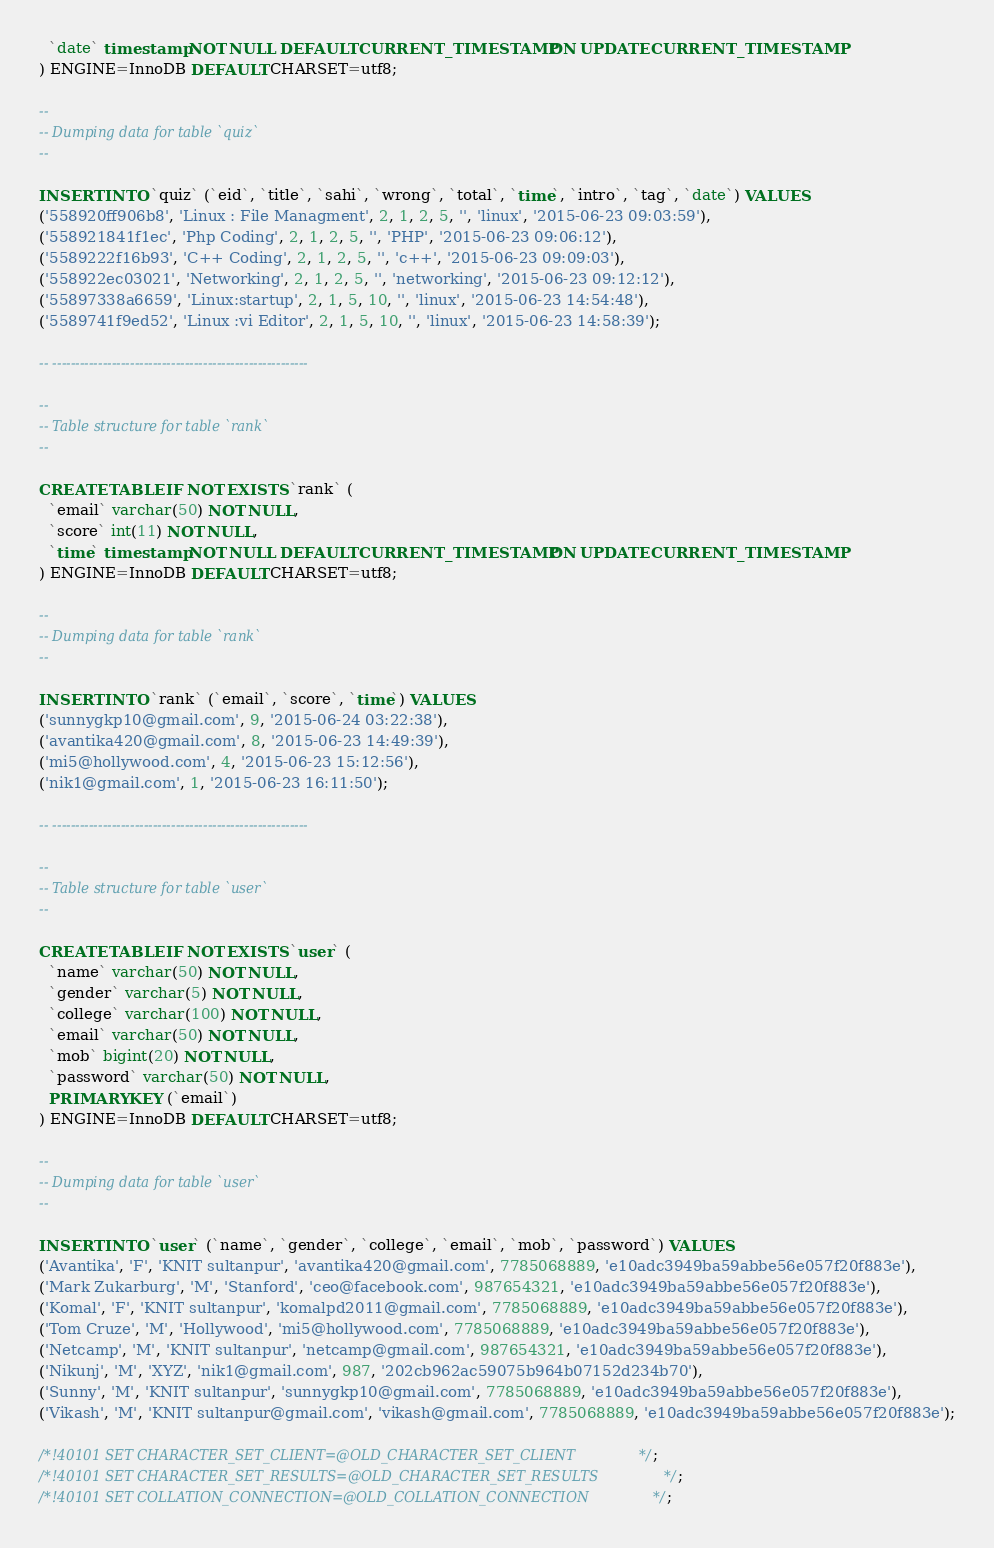Convert code to text. <code><loc_0><loc_0><loc_500><loc_500><_SQL_>  `date` timestamp NOT NULL DEFAULT CURRENT_TIMESTAMP ON UPDATE CURRENT_TIMESTAMP
) ENGINE=InnoDB DEFAULT CHARSET=utf8;

--
-- Dumping data for table `quiz`
--

INSERT INTO `quiz` (`eid`, `title`, `sahi`, `wrong`, `total`, `time`, `intro`, `tag`, `date`) VALUES
('558920ff906b8', 'Linux : File Managment', 2, 1, 2, 5, '', 'linux', '2015-06-23 09:03:59'),
('558921841f1ec', 'Php Coding', 2, 1, 2, 5, '', 'PHP', '2015-06-23 09:06:12'),
('5589222f16b93', 'C++ Coding', 2, 1, 2, 5, '', 'c++', '2015-06-23 09:09:03'),
('558922ec03021', 'Networking', 2, 1, 2, 5, '', 'networking', '2015-06-23 09:12:12'),
('55897338a6659', 'Linux:startup', 2, 1, 5, 10, '', 'linux', '2015-06-23 14:54:48'),
('5589741f9ed52', 'Linux :vi Editor', 2, 1, 5, 10, '', 'linux', '2015-06-23 14:58:39');

-- --------------------------------------------------------

--
-- Table structure for table `rank`
--

CREATE TABLE IF NOT EXISTS `rank` (
  `email` varchar(50) NOT NULL,
  `score` int(11) NOT NULL,
  `time` timestamp NOT NULL DEFAULT CURRENT_TIMESTAMP ON UPDATE CURRENT_TIMESTAMP
) ENGINE=InnoDB DEFAULT CHARSET=utf8;

--
-- Dumping data for table `rank`
--

INSERT INTO `rank` (`email`, `score`, `time`) VALUES
('sunnygkp10@gmail.com', 9, '2015-06-24 03:22:38'),
('avantika420@gmail.com', 8, '2015-06-23 14:49:39'),
('mi5@hollywood.com', 4, '2015-06-23 15:12:56'),
('nik1@gmail.com', 1, '2015-06-23 16:11:50');

-- --------------------------------------------------------

--
-- Table structure for table `user`
--

CREATE TABLE IF NOT EXISTS `user` (
  `name` varchar(50) NOT NULL,
  `gender` varchar(5) NOT NULL,
  `college` varchar(100) NOT NULL,
  `email` varchar(50) NOT NULL,
  `mob` bigint(20) NOT NULL,
  `password` varchar(50) NOT NULL,
  PRIMARY KEY (`email`)
) ENGINE=InnoDB DEFAULT CHARSET=utf8;

--
-- Dumping data for table `user`
--

INSERT INTO `user` (`name`, `gender`, `college`, `email`, `mob`, `password`) VALUES
('Avantika', 'F', 'KNIT sultanpur', 'avantika420@gmail.com', 7785068889, 'e10adc3949ba59abbe56e057f20f883e'),
('Mark Zukarburg', 'M', 'Stanford', 'ceo@facebook.com', 987654321, 'e10adc3949ba59abbe56e057f20f883e'),
('Komal', 'F', 'KNIT sultanpur', 'komalpd2011@gmail.com', 7785068889, 'e10adc3949ba59abbe56e057f20f883e'),
('Tom Cruze', 'M', 'Hollywood', 'mi5@hollywood.com', 7785068889, 'e10adc3949ba59abbe56e057f20f883e'),
('Netcamp', 'M', 'KNIT sultanpur', 'netcamp@gmail.com', 987654321, 'e10adc3949ba59abbe56e057f20f883e'),
('Nikunj', 'M', 'XYZ', 'nik1@gmail.com', 987, '202cb962ac59075b964b07152d234b70'),
('Sunny', 'M', 'KNIT sultanpur', 'sunnygkp10@gmail.com', 7785068889, 'e10adc3949ba59abbe56e057f20f883e'),
('Vikash', 'M', 'KNIT sultanpur@gmail.com', 'vikash@gmail.com', 7785068889, 'e10adc3949ba59abbe56e057f20f883e');

/*!40101 SET CHARACTER_SET_CLIENT=@OLD_CHARACTER_SET_CLIENT */;
/*!40101 SET CHARACTER_SET_RESULTS=@OLD_CHARACTER_SET_RESULTS */;
/*!40101 SET COLLATION_CONNECTION=@OLD_COLLATION_CONNECTION */;
</code> 